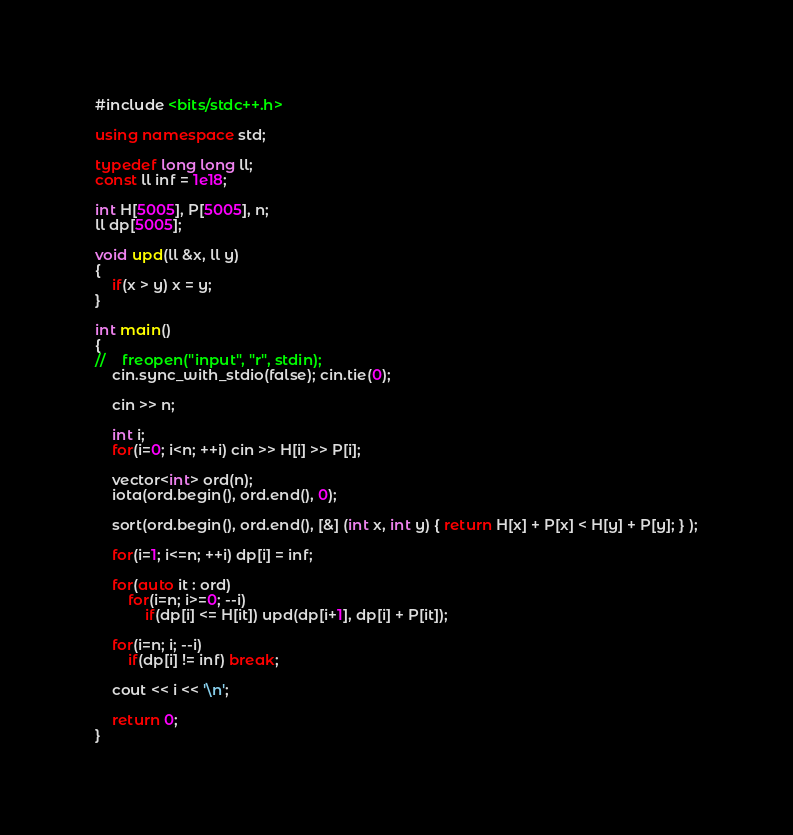Convert code to text. <code><loc_0><loc_0><loc_500><loc_500><_C++_>#include <bits/stdc++.h>

using namespace std;

typedef long long ll;
const ll inf = 1e18;

int H[5005], P[5005], n;
ll dp[5005];

void upd(ll &x, ll y)
{
    if(x > y) x = y;
}

int main()
{
//    freopen("input", "r", stdin);
    cin.sync_with_stdio(false); cin.tie(0);

    cin >> n;

    int i;
    for(i=0; i<n; ++i) cin >> H[i] >> P[i];

    vector<int> ord(n);
    iota(ord.begin(), ord.end(), 0);

    sort(ord.begin(), ord.end(), [&] (int x, int y) { return H[x] + P[x] < H[y] + P[y]; } );

    for(i=1; i<=n; ++i) dp[i] = inf;

    for(auto it : ord)
        for(i=n; i>=0; --i)
            if(dp[i] <= H[it]) upd(dp[i+1], dp[i] + P[it]);

    for(i=n; i; --i)
        if(dp[i] != inf) break;

    cout << i << '\n';

    return 0;
}
</code> 